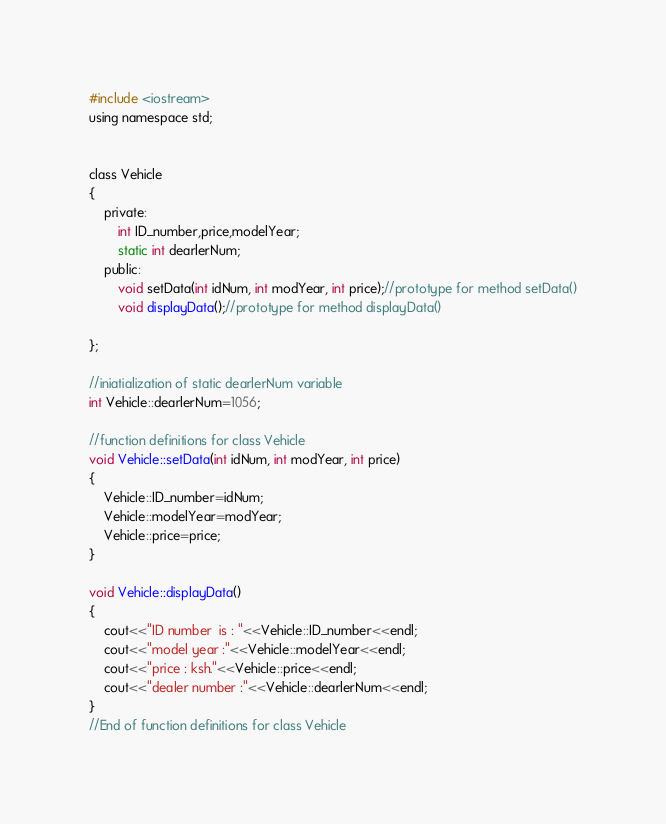<code> <loc_0><loc_0><loc_500><loc_500><_C_>#include <iostream>
using namespace std;


class Vehicle
{
	private:
		int ID_number,price,modelYear;
		static int dearlerNum;
	public:
		void setData(int idNum, int modYear, int price);//prototype for method setData()
		void displayData();//prototype for method displayData()

};

//iniatialization of static dearlerNum variable
int Vehicle::dearlerNum=1056;

//function definitions for class Vehicle
void Vehicle::setData(int idNum, int modYear, int price)
{
	Vehicle::ID_number=idNum;
	Vehicle::modelYear=modYear;
	Vehicle::price=price;
}

void Vehicle::displayData()
{
	cout<<"ID number  is : "<<Vehicle::ID_number<<endl;
	cout<<"model year :"<<Vehicle::modelYear<<endl;
	cout<<"price : ksh."<<Vehicle::price<<endl;
	cout<<"dealer number :"<<Vehicle::dearlerNum<<endl;
}
//End of function definitions for class Vehicle


</code> 